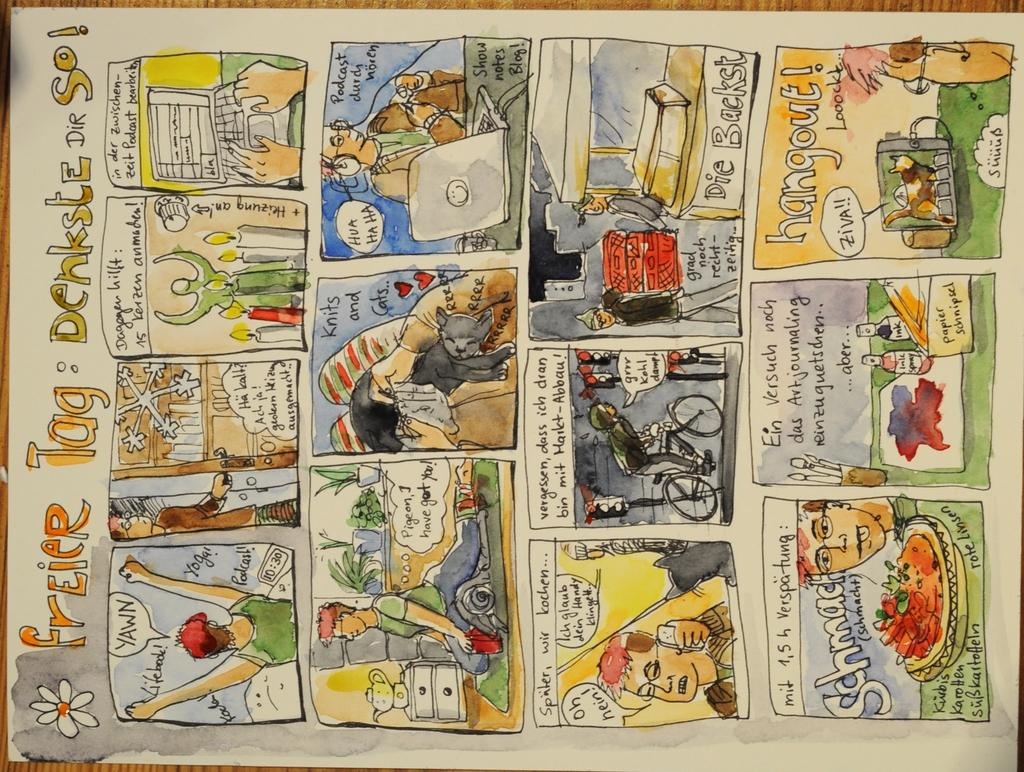<image>
Create a compact narrative representing the image presented. A comic strip from a newspaper with the title Freier Tag Denksle Dir So.. 